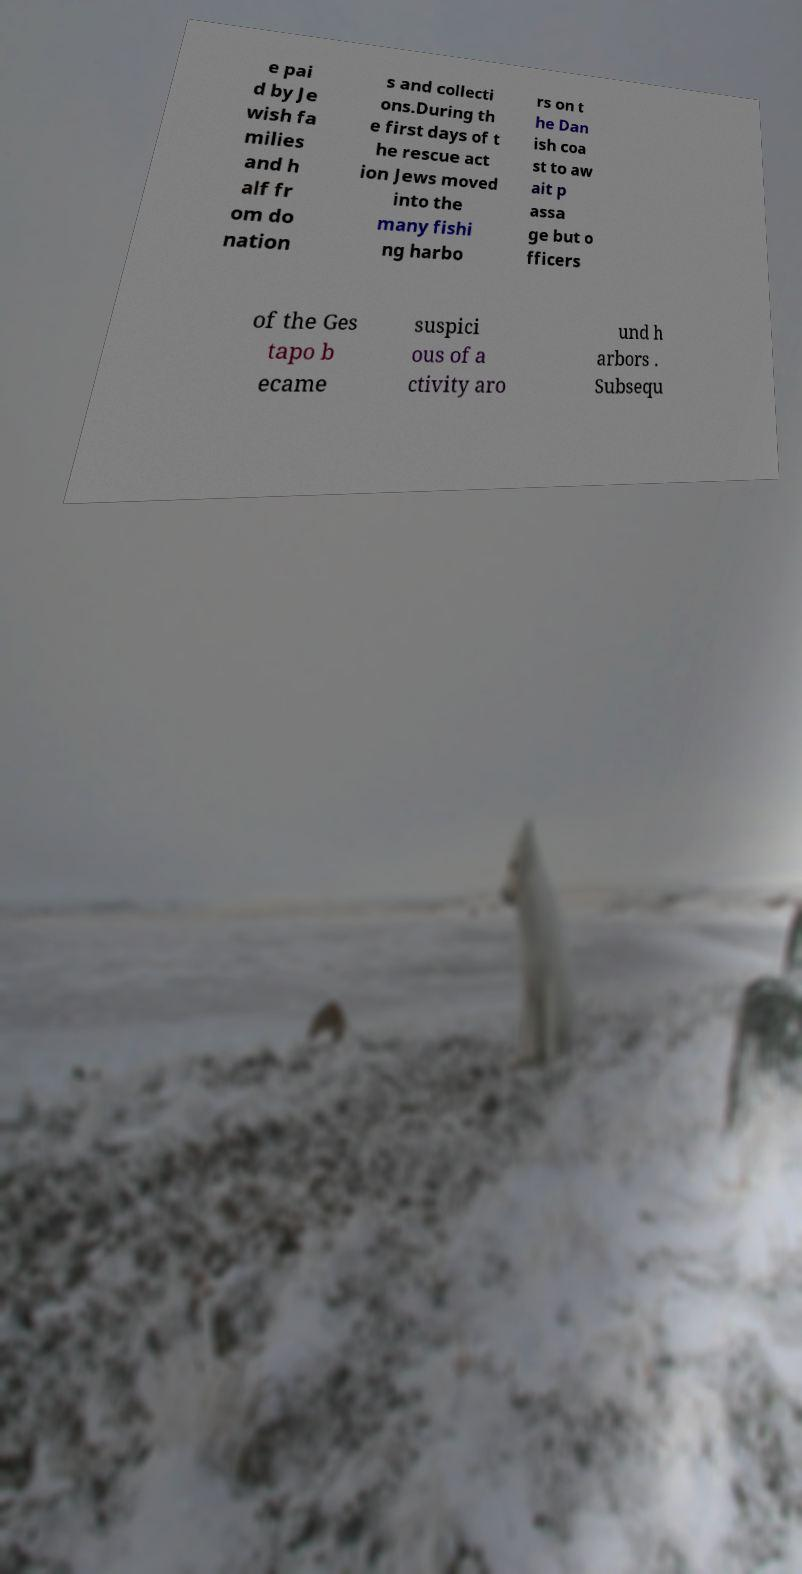Please read and relay the text visible in this image. What does it say? e pai d by Je wish fa milies and h alf fr om do nation s and collecti ons.During th e first days of t he rescue act ion Jews moved into the many fishi ng harbo rs on t he Dan ish coa st to aw ait p assa ge but o fficers of the Ges tapo b ecame suspici ous of a ctivity aro und h arbors . Subsequ 